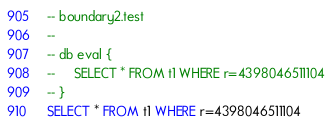<code> <loc_0><loc_0><loc_500><loc_500><_SQL_>-- boundary2.test
-- 
-- db eval {
--     SELECT * FROM t1 WHERE r=4398046511104
-- }
SELECT * FROM t1 WHERE r=4398046511104</code> 